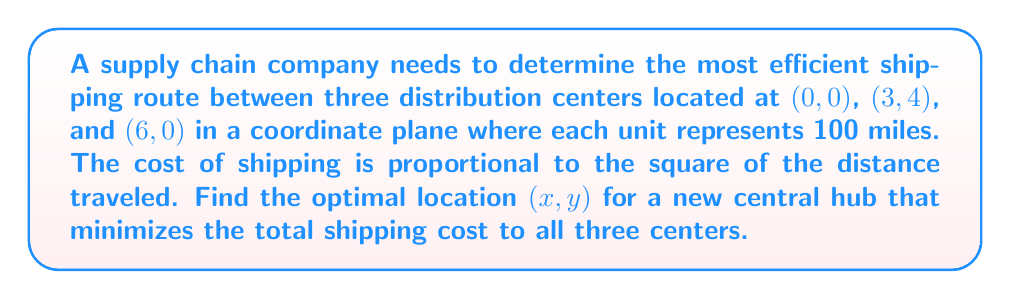Provide a solution to this math problem. Let's approach this step-by-step using multivariable calculus:

1) First, we need to set up our cost function. The cost is proportional to the square of the distance, so for each center, the cost will be of the form $k(x^2 + y^2)$ where $k$ is some constant. We can ignore this constant as it doesn't affect the optimization.

2) Our total cost function $C(x,y)$ will be the sum of the costs to each center:

   $C(x,y) = x^2 + y^2 + ((x-3)^2 + (y-4)^2) + ((x-6)^2 + y^2)$

3) To find the minimum, we need to find where the partial derivatives of $C$ with respect to $x$ and $y$ are both zero:

   $\frac{\partial C}{\partial x} = 2x + 2(x-3) + 2(x-6) = 6x - 18 = 0$
   $\frac{\partial C}{\partial y} = 2y + 2(y-4) + 2y = 6y - 8 = 0$

4) Solving these equations:

   From $\frac{\partial C}{\partial x}$: $6x = 18$, so $x = 3$
   From $\frac{\partial C}{\partial y}$: $6y = 8$, so $y = \frac{4}{3}$

5) To confirm this is a minimum, we could check the second derivatives, but given the nature of the problem (all positive quadratic terms), this point must be a global minimum.

6) Therefore, the optimal location for the new hub is $(3, \frac{4}{3})$.

[asy]
unitsize(1cm);
draw((-1,-1)--(7,5), gray);
dot((0,0));
dot((3,4));
dot((6,0));
dot((3,4/3), red);
label("(0,0)", (0,0), SW);
label("(3,4)", (3,4), NE);
label("(6,0)", (6,0), SE);
label("(3,4/3)", (3,4/3), NE, red);
[/asy]
Answer: $(3, \frac{4}{3})$ 